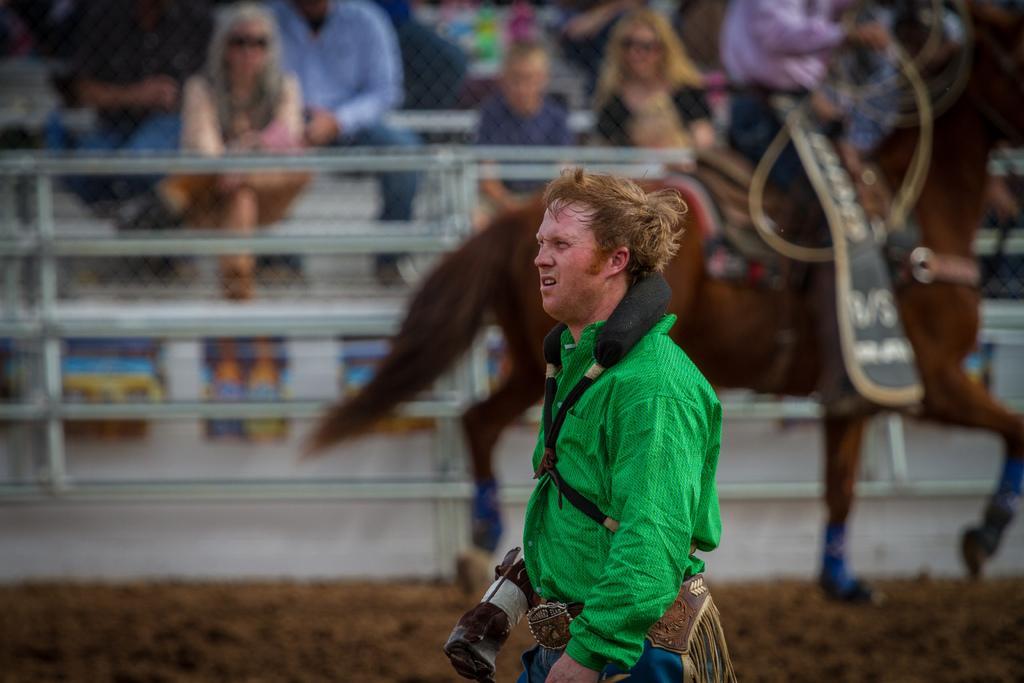Can you describe this image briefly? In the center we can see one man is standing. And back of him we can see the horse. And coming to the background we can see some people were sitting. 